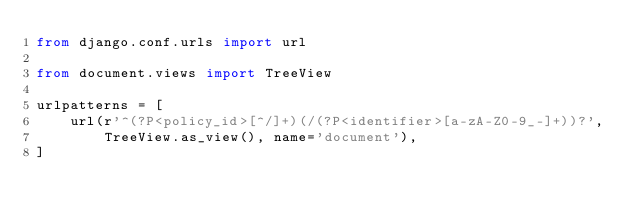Convert code to text. <code><loc_0><loc_0><loc_500><loc_500><_Python_>from django.conf.urls import url

from document.views import TreeView

urlpatterns = [
    url(r'^(?P<policy_id>[^/]+)(/(?P<identifier>[a-zA-Z0-9_-]+))?',
        TreeView.as_view(), name='document'),
]
</code> 